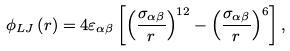Convert formula to latex. <formula><loc_0><loc_0><loc_500><loc_500>\phi _ { L J } \left ( r \right ) = 4 \varepsilon _ { \alpha \beta } \left [ \left ( \frac { \sigma _ { \alpha \beta } } { r } \right ) ^ { 1 2 } - \left ( \frac { \sigma _ { \alpha \beta } } { r } \right ) ^ { 6 } \right ] ,</formula> 